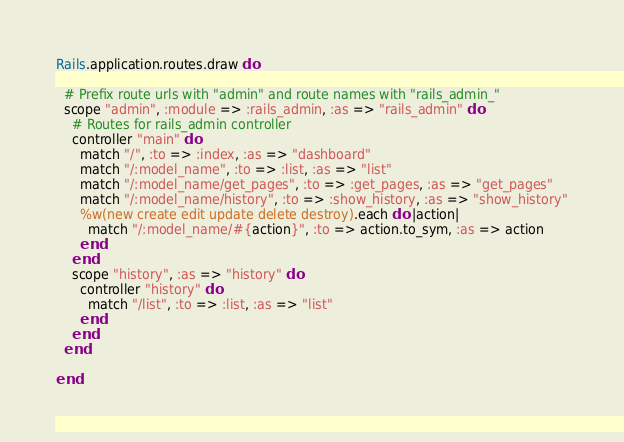Convert code to text. <code><loc_0><loc_0><loc_500><loc_500><_Ruby_>Rails.application.routes.draw do

  # Prefix route urls with "admin" and route names with "rails_admin_"
  scope "admin", :module => :rails_admin, :as => "rails_admin" do
    # Routes for rails_admin controller
    controller "main" do
      match "/", :to => :index, :as => "dashboard"
      match "/:model_name", :to => :list, :as => "list"
      match "/:model_name/get_pages", :to => :get_pages, :as => "get_pages"
      match "/:model_name/history", :to => :show_history, :as => "show_history"
      %w(new create edit update delete destroy).each do |action|
        match "/:model_name/#{action}", :to => action.to_sym, :as => action
      end
    end
    scope "history", :as => "history" do
      controller "history" do
        match "/list", :to => :list, :as => "list"
      end
    end
  end

end
</code> 